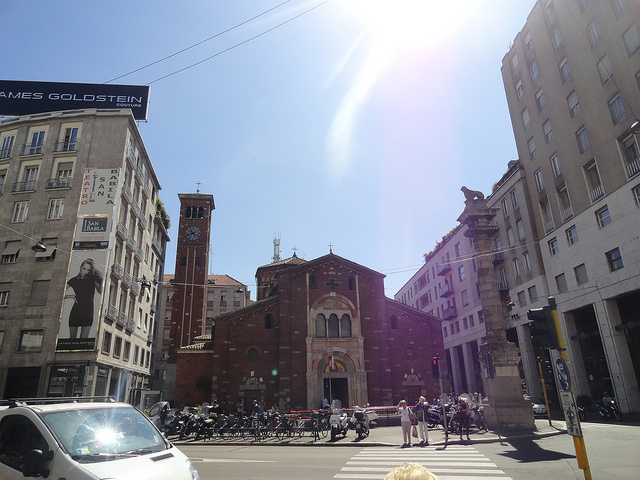What is the theater straight ahead? The structure seen straight ahead in the image is actually the Basilica of San Lorenzo Maggiore, which is a historic church in Milan, not a theater. It's known for its ancient origins and remarkable architectural design. 